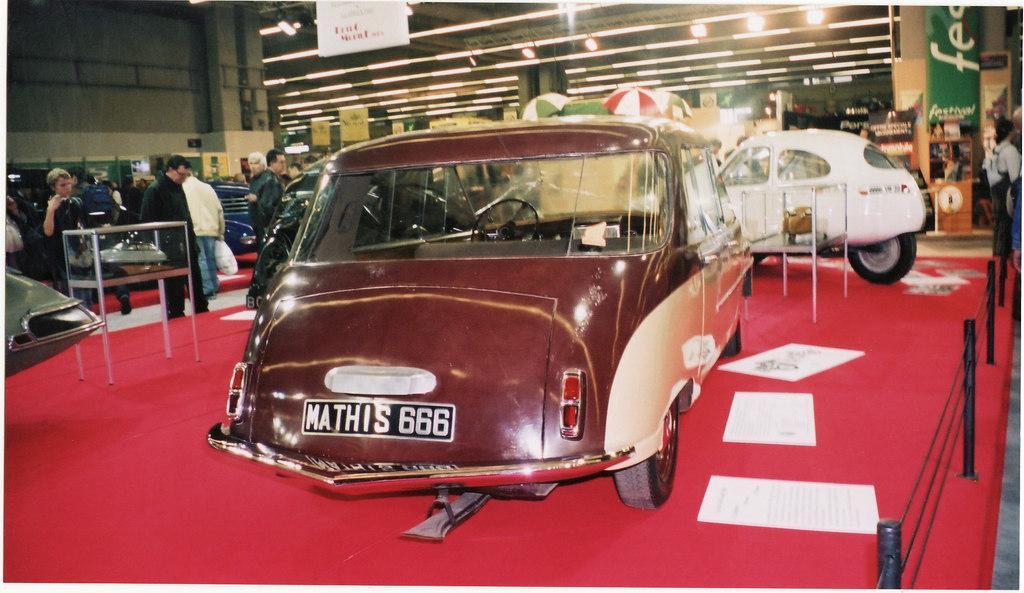Can you describe this image briefly? There are cars on the red carpet. On the carpet some papers are there. On the right side there is railing with poles. On the left side some people are standing. In the background there are umbrellas, banners, lights and is looking blurred in the background. 